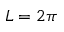Convert formula to latex. <formula><loc_0><loc_0><loc_500><loc_500>L = 2 \pi</formula> 